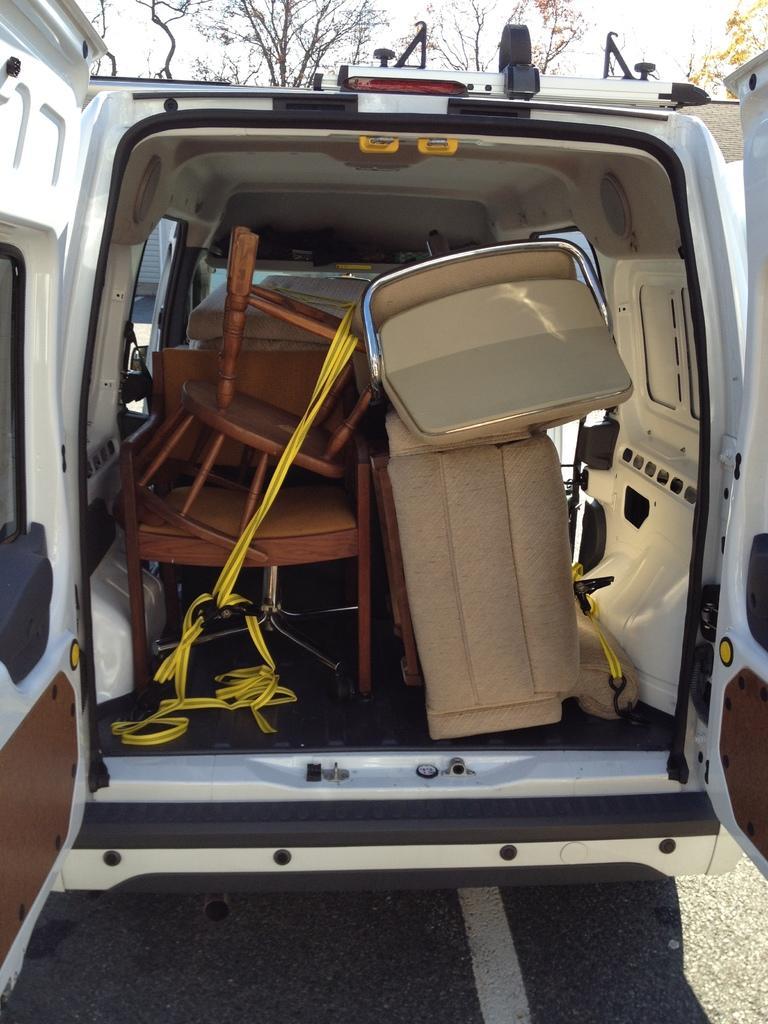Can you describe this image briefly? In the image that is a vehicle and the back door of the vehicle is opened, inside the vehicle there are some furniture, behind the vehicle there are trees. 